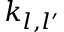<formula> <loc_0><loc_0><loc_500><loc_500>k _ { l , l ^ { \prime } }</formula> 